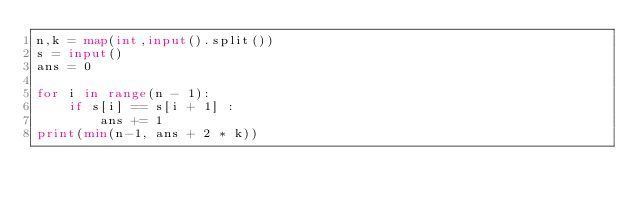<code> <loc_0><loc_0><loc_500><loc_500><_Python_>n,k = map(int,input().split())
s = input()
ans = 0
 
for i in range(n - 1):
    if s[i] == s[i + 1] :
        ans += 1
print(min(n-1, ans + 2 * k))</code> 